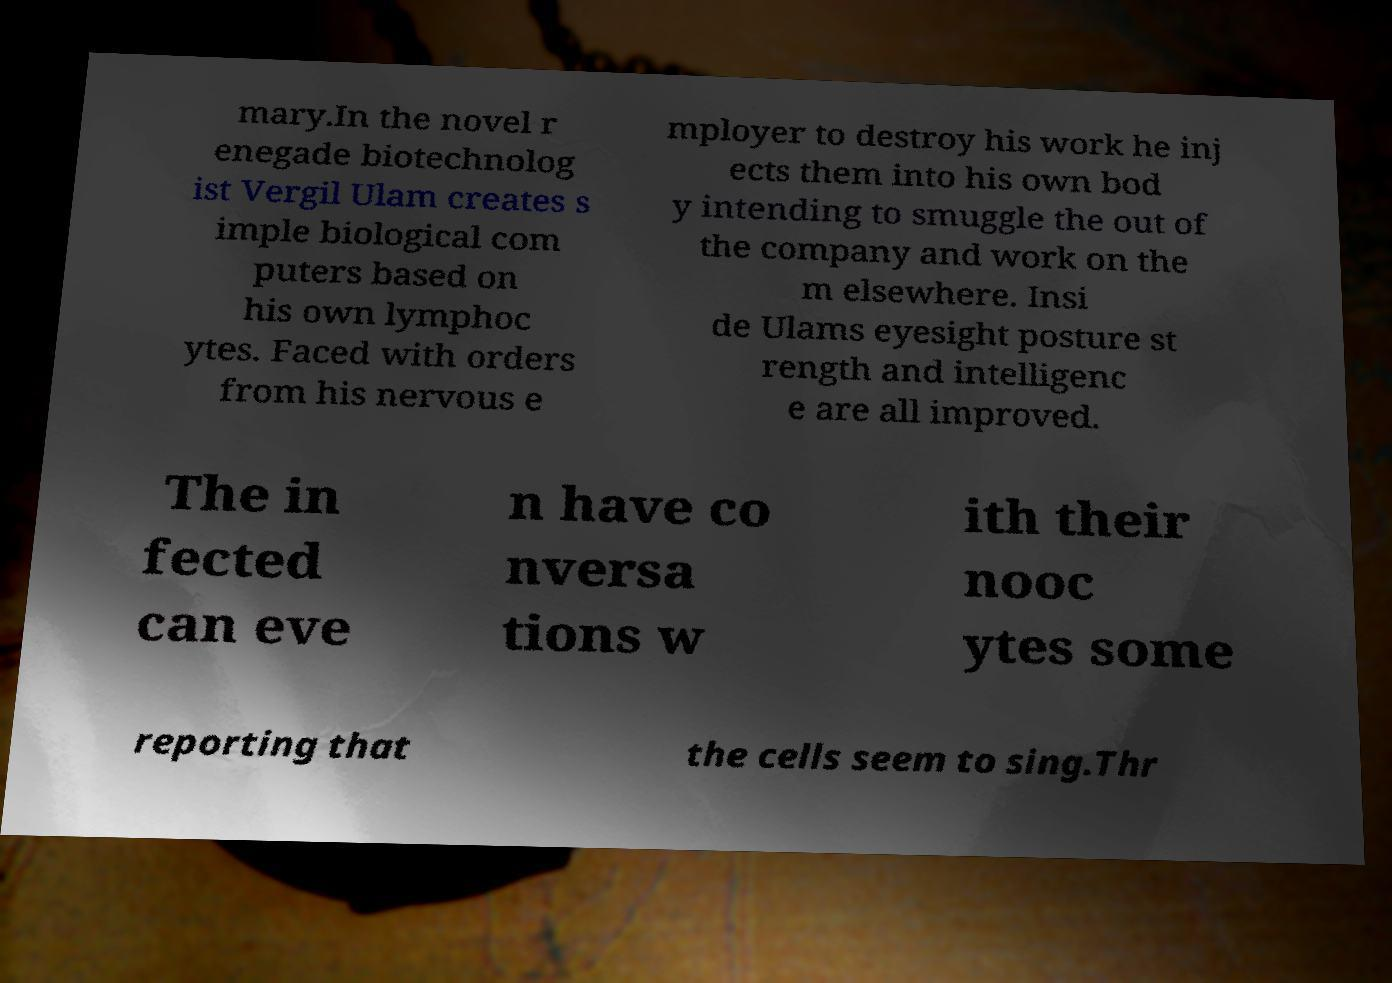Could you assist in decoding the text presented in this image and type it out clearly? mary.In the novel r enegade biotechnolog ist Vergil Ulam creates s imple biological com puters based on his own lymphoc ytes. Faced with orders from his nervous e mployer to destroy his work he inj ects them into his own bod y intending to smuggle the out of the company and work on the m elsewhere. Insi de Ulams eyesight posture st rength and intelligenc e are all improved. The in fected can eve n have co nversa tions w ith their nooc ytes some reporting that the cells seem to sing.Thr 